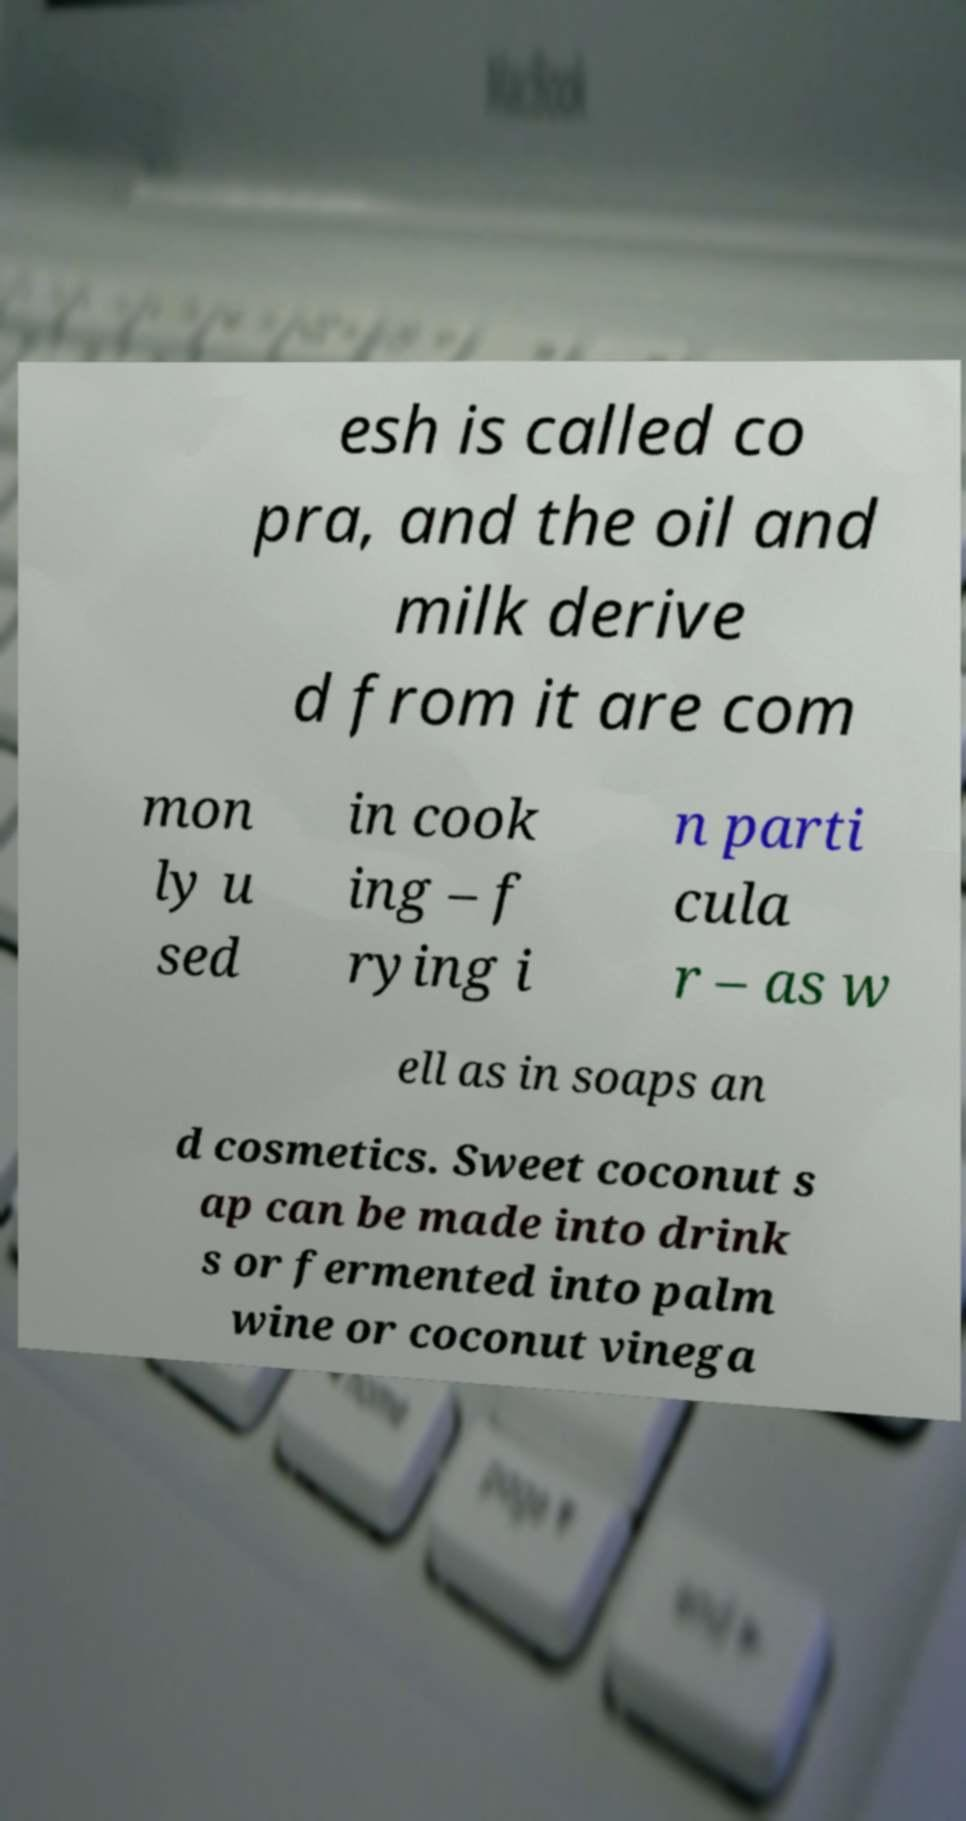Please read and relay the text visible in this image. What does it say? esh is called co pra, and the oil and milk derive d from it are com mon ly u sed in cook ing – f rying i n parti cula r – as w ell as in soaps an d cosmetics. Sweet coconut s ap can be made into drink s or fermented into palm wine or coconut vinega 